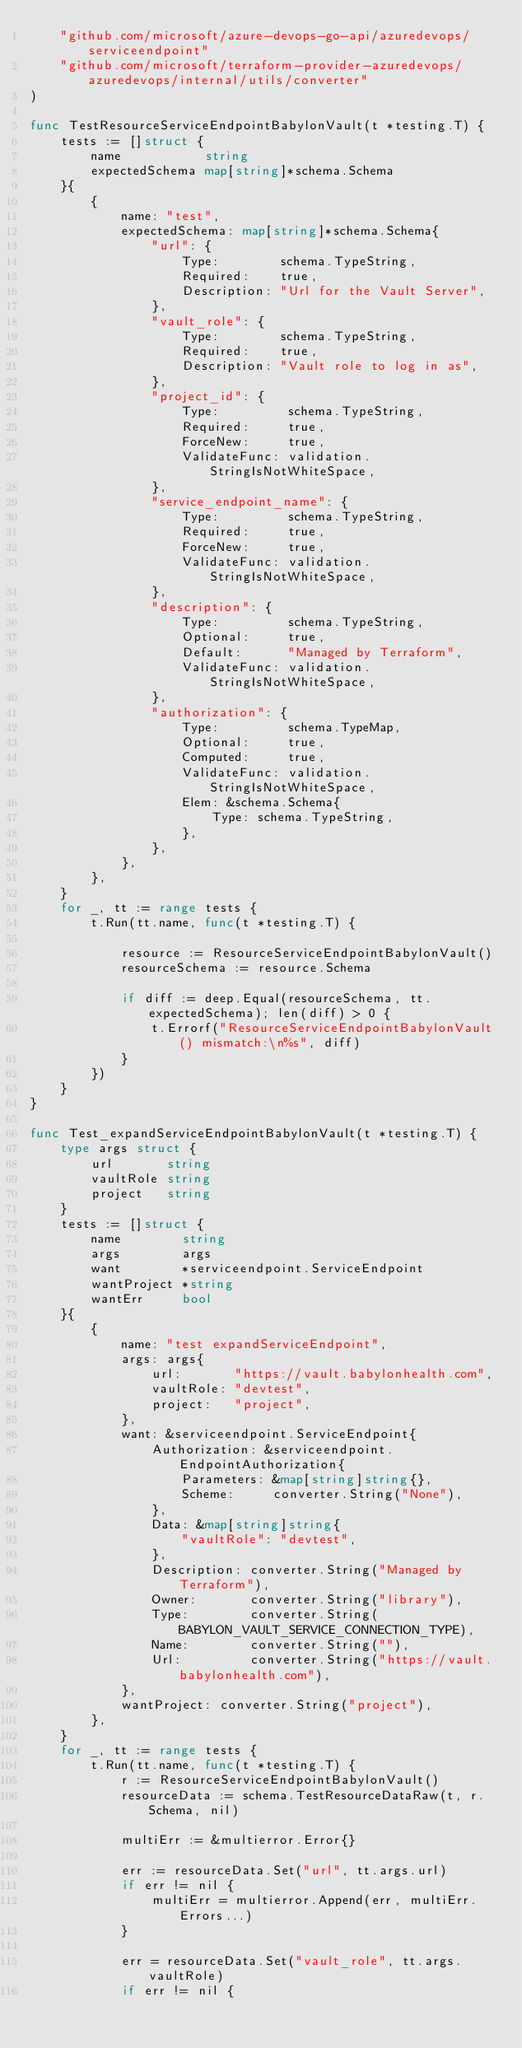<code> <loc_0><loc_0><loc_500><loc_500><_Go_>	"github.com/microsoft/azure-devops-go-api/azuredevops/serviceendpoint"
	"github.com/microsoft/terraform-provider-azuredevops/azuredevops/internal/utils/converter"
)

func TestResourceServiceEndpointBabylonVault(t *testing.T) {
	tests := []struct {
		name           string
		expectedSchema map[string]*schema.Schema
	}{
		{
			name: "test",
			expectedSchema: map[string]*schema.Schema{
				"url": {
					Type:        schema.TypeString,
					Required:    true,
					Description: "Url for the Vault Server",
				},
				"vault_role": {
					Type:        schema.TypeString,
					Required:    true,
					Description: "Vault role to log in as",
				},
				"project_id": {
					Type:         schema.TypeString,
					Required:     true,
					ForceNew:     true,
					ValidateFunc: validation.StringIsNotWhiteSpace,
				},
				"service_endpoint_name": {
					Type:         schema.TypeString,
					Required:     true,
					ForceNew:     true,
					ValidateFunc: validation.StringIsNotWhiteSpace,
				},
				"description": {
					Type:         schema.TypeString,
					Optional:     true,
					Default:      "Managed by Terraform",
					ValidateFunc: validation.StringIsNotWhiteSpace,
				},
				"authorization": {
					Type:         schema.TypeMap,
					Optional:     true,
					Computed:     true,
					ValidateFunc: validation.StringIsNotWhiteSpace,
					Elem: &schema.Schema{
						Type: schema.TypeString,
					},
				},
			},
		},
	}
	for _, tt := range tests {
		t.Run(tt.name, func(t *testing.T) {

			resource := ResourceServiceEndpointBabylonVault()
			resourceSchema := resource.Schema

			if diff := deep.Equal(resourceSchema, tt.expectedSchema); len(diff) > 0 {
				t.Errorf("ResourceServiceEndpointBabylonVault() mismatch:\n%s", diff)
			}
		})
	}
}

func Test_expandServiceEndpointBabylonVault(t *testing.T) {
	type args struct {
		url       string
		vaultRole string
		project   string
	}
	tests := []struct {
		name        string
		args        args
		want        *serviceendpoint.ServiceEndpoint
		wantProject *string
		wantErr     bool
	}{
		{
			name: "test expandServiceEndpoint",
			args: args{
				url:       "https://vault.babylonhealth.com",
				vaultRole: "devtest",
				project:   "project",
			},
			want: &serviceendpoint.ServiceEndpoint{
				Authorization: &serviceendpoint.EndpointAuthorization{
					Parameters: &map[string]string{},
					Scheme:     converter.String("None"),
				},
				Data: &map[string]string{
					"vaultRole": "devtest",
				},
				Description: converter.String("Managed by Terraform"),
				Owner:       converter.String("library"),
				Type:        converter.String(BABYLON_VAULT_SERVICE_CONNECTION_TYPE),
				Name:        converter.String(""),
				Url:         converter.String("https://vault.babylonhealth.com"),
			},
			wantProject: converter.String("project"),
		},
	}
	for _, tt := range tests {
		t.Run(tt.name, func(t *testing.T) {
			r := ResourceServiceEndpointBabylonVault()
			resourceData := schema.TestResourceDataRaw(t, r.Schema, nil)

			multiErr := &multierror.Error{}

			err := resourceData.Set("url", tt.args.url)
			if err != nil {
				multiErr = multierror.Append(err, multiErr.Errors...)
			}

			err = resourceData.Set("vault_role", tt.args.vaultRole)
			if err != nil {</code> 